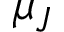<formula> <loc_0><loc_0><loc_500><loc_500>\mu _ { J }</formula> 